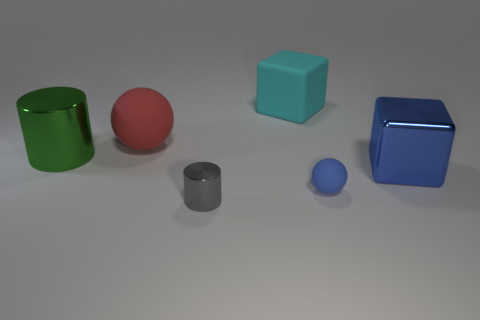What might be the purpose of this arrangement? This arrangement appears to be a simple display of geometric shapes and colors, possibly for a visual demonstration or an art composition. It showcases different forms and how they interact with light, shade, and reflectivity in a neutral setting. 